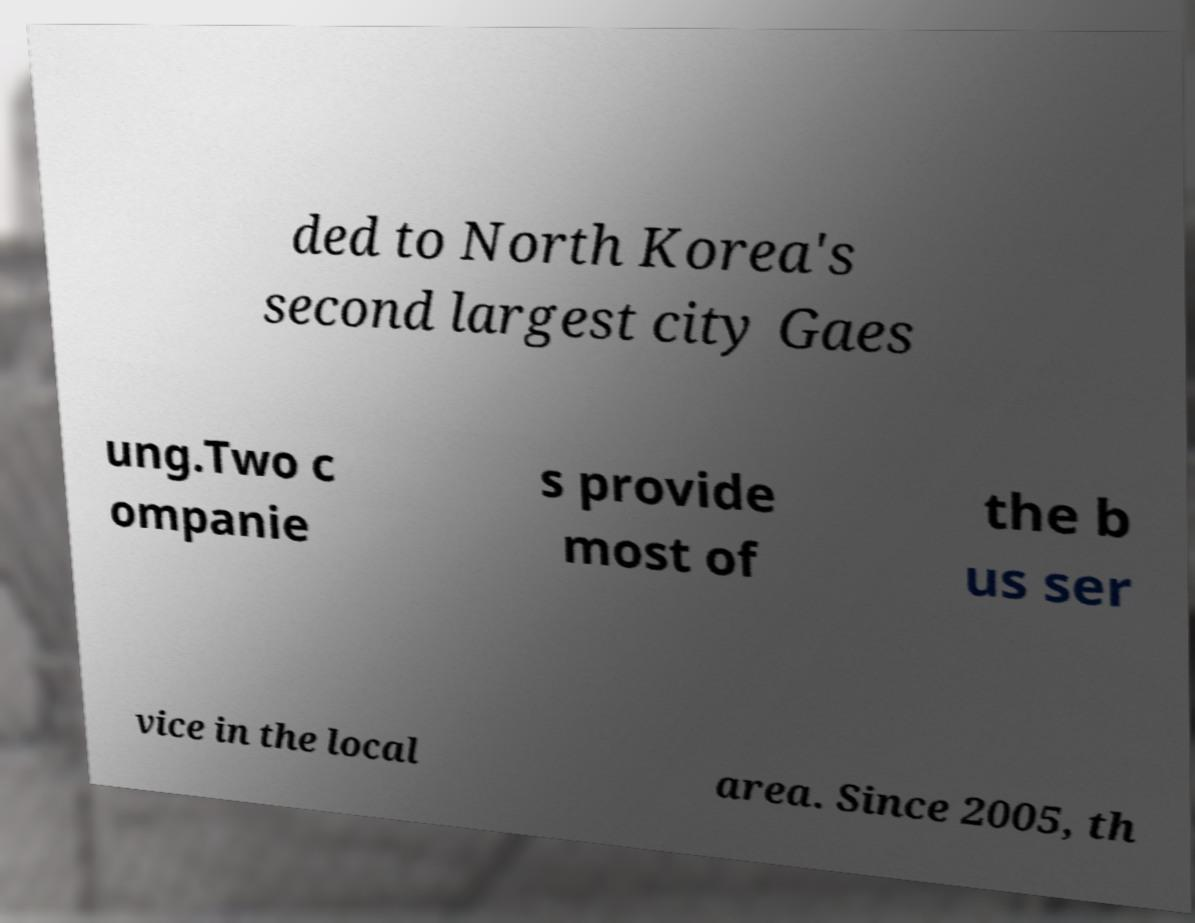Could you assist in decoding the text presented in this image and type it out clearly? ded to North Korea's second largest city Gaes ung.Two c ompanie s provide most of the b us ser vice in the local area. Since 2005, th 